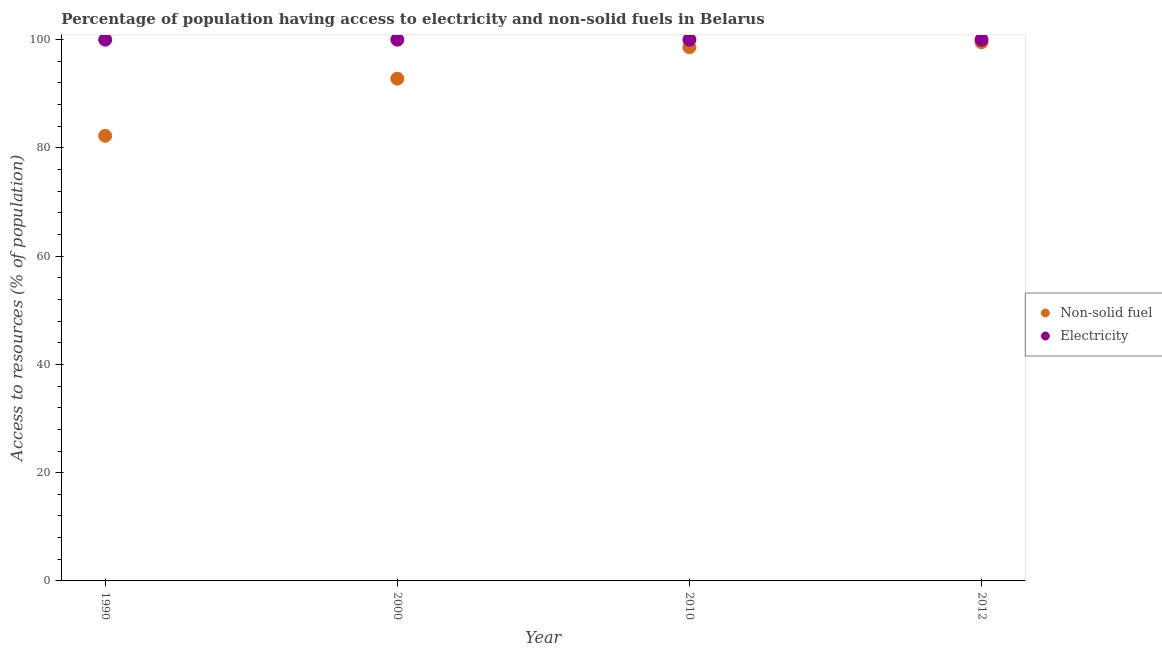How many different coloured dotlines are there?
Provide a short and direct response. 2. What is the percentage of population having access to electricity in 2010?
Make the answer very short. 100. Across all years, what is the maximum percentage of population having access to electricity?
Offer a very short reply. 100. Across all years, what is the minimum percentage of population having access to electricity?
Offer a very short reply. 100. In which year was the percentage of population having access to non-solid fuel minimum?
Your response must be concise. 1990. What is the total percentage of population having access to electricity in the graph?
Ensure brevity in your answer.  400. What is the difference between the percentage of population having access to non-solid fuel in 2000 and that in 2010?
Your answer should be compact. -5.8. What is the difference between the percentage of population having access to non-solid fuel in 1990 and the percentage of population having access to electricity in 2012?
Offer a very short reply. -17.76. What is the average percentage of population having access to non-solid fuel per year?
Make the answer very short. 93.29. In the year 2010, what is the difference between the percentage of population having access to electricity and percentage of population having access to non-solid fuel?
Provide a succinct answer. 1.4. In how many years, is the percentage of population having access to electricity greater than 4 %?
Ensure brevity in your answer.  4. What is the ratio of the percentage of population having access to non-solid fuel in 2000 to that in 2012?
Provide a succinct answer. 0.93. Is the difference between the percentage of population having access to electricity in 1990 and 2010 greater than the difference between the percentage of population having access to non-solid fuel in 1990 and 2010?
Give a very brief answer. Yes. What is the difference between the highest and the second highest percentage of population having access to electricity?
Your response must be concise. 0. What is the difference between the highest and the lowest percentage of population having access to non-solid fuel?
Make the answer very short. 17.29. In how many years, is the percentage of population having access to non-solid fuel greater than the average percentage of population having access to non-solid fuel taken over all years?
Keep it short and to the point. 2. Does the percentage of population having access to electricity monotonically increase over the years?
Your answer should be very brief. No. Is the percentage of population having access to electricity strictly greater than the percentage of population having access to non-solid fuel over the years?
Your answer should be very brief. Yes. Is the percentage of population having access to electricity strictly less than the percentage of population having access to non-solid fuel over the years?
Offer a terse response. No. How many dotlines are there?
Make the answer very short. 2. How many years are there in the graph?
Offer a terse response. 4. What is the difference between two consecutive major ticks on the Y-axis?
Keep it short and to the point. 20. Does the graph contain grids?
Ensure brevity in your answer.  No. Where does the legend appear in the graph?
Keep it short and to the point. Center right. How many legend labels are there?
Your response must be concise. 2. How are the legend labels stacked?
Provide a succinct answer. Vertical. What is the title of the graph?
Keep it short and to the point. Percentage of population having access to electricity and non-solid fuels in Belarus. Does "Quality of trade" appear as one of the legend labels in the graph?
Provide a short and direct response. No. What is the label or title of the Y-axis?
Your response must be concise. Access to resources (% of population). What is the Access to resources (% of population) of Non-solid fuel in 1990?
Provide a short and direct response. 82.24. What is the Access to resources (% of population) in Non-solid fuel in 2000?
Your response must be concise. 92.8. What is the Access to resources (% of population) in Electricity in 2000?
Your answer should be compact. 100. What is the Access to resources (% of population) in Non-solid fuel in 2010?
Offer a terse response. 98.6. What is the Access to resources (% of population) in Non-solid fuel in 2012?
Offer a very short reply. 99.53. Across all years, what is the maximum Access to resources (% of population) of Non-solid fuel?
Provide a succinct answer. 99.53. Across all years, what is the maximum Access to resources (% of population) in Electricity?
Give a very brief answer. 100. Across all years, what is the minimum Access to resources (% of population) of Non-solid fuel?
Offer a very short reply. 82.24. Across all years, what is the minimum Access to resources (% of population) of Electricity?
Your answer should be compact. 100. What is the total Access to resources (% of population) of Non-solid fuel in the graph?
Ensure brevity in your answer.  373.16. What is the difference between the Access to resources (% of population) of Non-solid fuel in 1990 and that in 2000?
Provide a succinct answer. -10.56. What is the difference between the Access to resources (% of population) of Non-solid fuel in 1990 and that in 2010?
Your answer should be compact. -16.36. What is the difference between the Access to resources (% of population) in Non-solid fuel in 1990 and that in 2012?
Make the answer very short. -17.29. What is the difference between the Access to resources (% of population) of Electricity in 1990 and that in 2012?
Make the answer very short. 0. What is the difference between the Access to resources (% of population) of Non-solid fuel in 2000 and that in 2010?
Make the answer very short. -5.8. What is the difference between the Access to resources (% of population) in Non-solid fuel in 2000 and that in 2012?
Ensure brevity in your answer.  -6.73. What is the difference between the Access to resources (% of population) of Non-solid fuel in 2010 and that in 2012?
Provide a succinct answer. -0.93. What is the difference between the Access to resources (% of population) of Non-solid fuel in 1990 and the Access to resources (% of population) of Electricity in 2000?
Ensure brevity in your answer.  -17.76. What is the difference between the Access to resources (% of population) in Non-solid fuel in 1990 and the Access to resources (% of population) in Electricity in 2010?
Offer a terse response. -17.76. What is the difference between the Access to resources (% of population) in Non-solid fuel in 1990 and the Access to resources (% of population) in Electricity in 2012?
Keep it short and to the point. -17.76. What is the difference between the Access to resources (% of population) in Non-solid fuel in 2000 and the Access to resources (% of population) in Electricity in 2010?
Ensure brevity in your answer.  -7.2. What is the difference between the Access to resources (% of population) of Non-solid fuel in 2000 and the Access to resources (% of population) of Electricity in 2012?
Keep it short and to the point. -7.2. What is the difference between the Access to resources (% of population) in Non-solid fuel in 2010 and the Access to resources (% of population) in Electricity in 2012?
Your answer should be compact. -1.4. What is the average Access to resources (% of population) in Non-solid fuel per year?
Offer a very short reply. 93.29. In the year 1990, what is the difference between the Access to resources (% of population) of Non-solid fuel and Access to resources (% of population) of Electricity?
Your answer should be compact. -17.76. In the year 2000, what is the difference between the Access to resources (% of population) in Non-solid fuel and Access to resources (% of population) in Electricity?
Offer a very short reply. -7.2. In the year 2010, what is the difference between the Access to resources (% of population) in Non-solid fuel and Access to resources (% of population) in Electricity?
Your answer should be compact. -1.4. In the year 2012, what is the difference between the Access to resources (% of population) of Non-solid fuel and Access to resources (% of population) of Electricity?
Your answer should be compact. -0.47. What is the ratio of the Access to resources (% of population) of Non-solid fuel in 1990 to that in 2000?
Your answer should be very brief. 0.89. What is the ratio of the Access to resources (% of population) of Electricity in 1990 to that in 2000?
Offer a terse response. 1. What is the ratio of the Access to resources (% of population) of Non-solid fuel in 1990 to that in 2010?
Give a very brief answer. 0.83. What is the ratio of the Access to resources (% of population) in Electricity in 1990 to that in 2010?
Your answer should be compact. 1. What is the ratio of the Access to resources (% of population) in Non-solid fuel in 1990 to that in 2012?
Provide a short and direct response. 0.83. What is the ratio of the Access to resources (% of population) in Electricity in 2000 to that in 2010?
Offer a terse response. 1. What is the ratio of the Access to resources (% of population) of Non-solid fuel in 2000 to that in 2012?
Keep it short and to the point. 0.93. What is the ratio of the Access to resources (% of population) in Electricity in 2000 to that in 2012?
Ensure brevity in your answer.  1. What is the ratio of the Access to resources (% of population) in Non-solid fuel in 2010 to that in 2012?
Your response must be concise. 0.99. What is the difference between the highest and the second highest Access to resources (% of population) in Non-solid fuel?
Give a very brief answer. 0.93. What is the difference between the highest and the second highest Access to resources (% of population) in Electricity?
Offer a terse response. 0. What is the difference between the highest and the lowest Access to resources (% of population) in Non-solid fuel?
Your answer should be very brief. 17.29. 